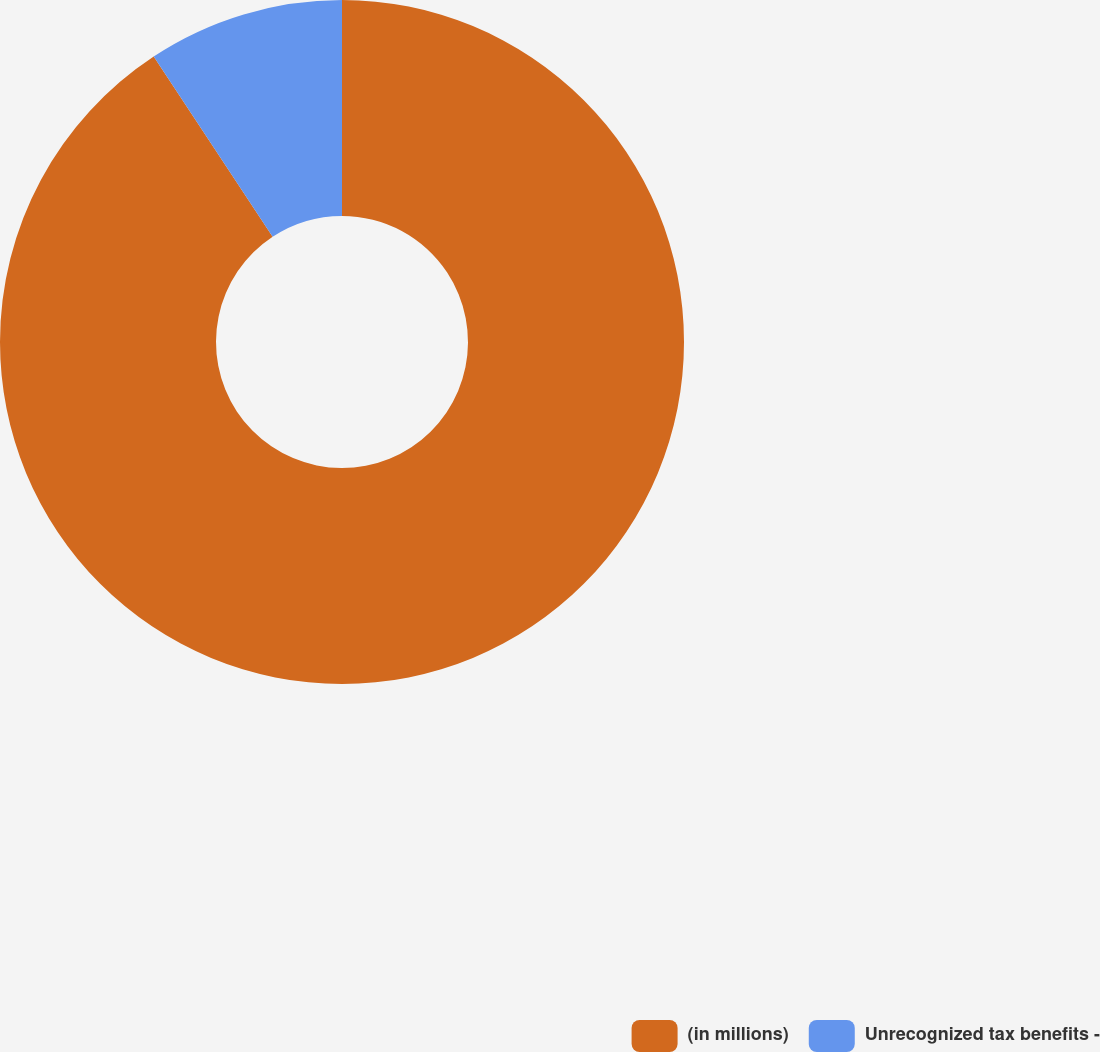Convert chart. <chart><loc_0><loc_0><loc_500><loc_500><pie_chart><fcel>(in millions)<fcel>Unrecognized tax benefits -<nl><fcel>90.72%<fcel>9.28%<nl></chart> 